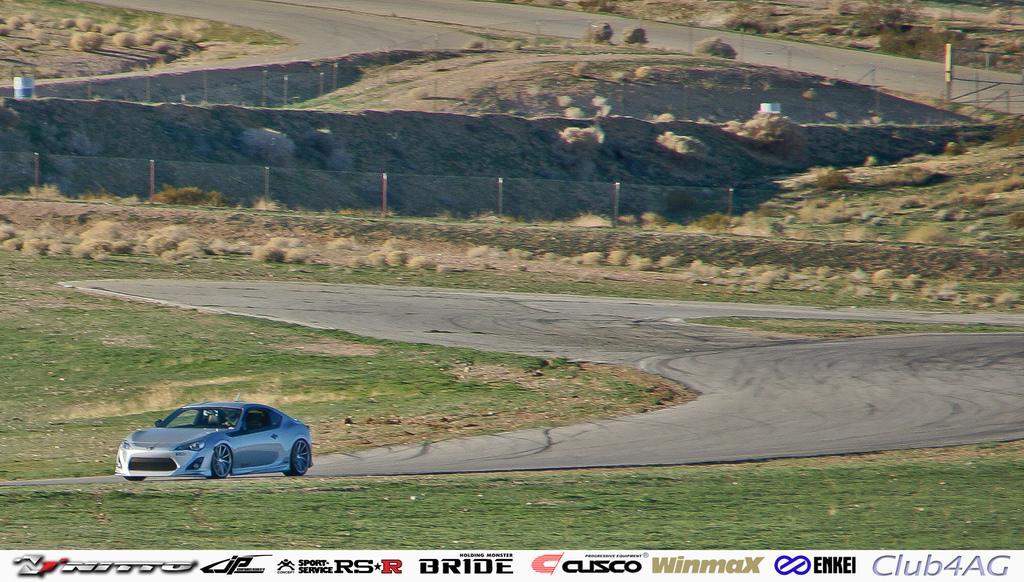Please provide a concise description of this image. This picture is clicked outside. In the foreground we can see the green grass and a car seems to be running on the road. In the background we can see the net, metal rods, rocks, grass, plants and some objects. At the bottom we can see the watermark on the image. 